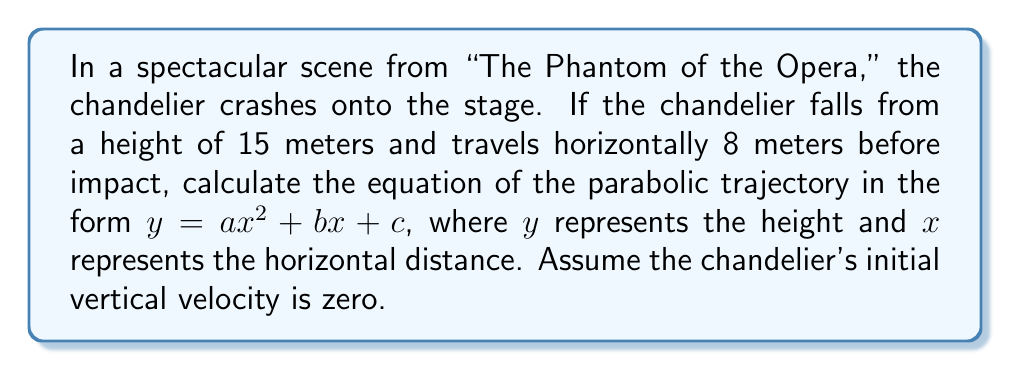Teach me how to tackle this problem. Let's approach this step-by-step:

1) The general equation for a parabola is $y = ax^2 + bx + c$, where:
   - $a$ determines the parabola's shape
   - $b$ affects the parabola's axis of symmetry
   - $c$ is the y-intercept (initial height)

2) We know three things:
   - The initial height (y-intercept) is 15 meters, so $c = 15$
   - The final height is 0 meters when x = 8 meters
   - The initial vertical velocity is zero, meaning the parabola is symmetrical

3) Because the parabola is symmetrical, its axis of symmetry is at $x = 4$ (half of 8).

4) For a symmetrical parabola, $b = -4a$ (where 4 is the x-coordinate of the axis of symmetry).

5) Now we can use the point (8, 0) to find $a$:

   $0 = a(8)^2 + (-4a)(8) + 15$
   $0 = 64a - 32a + 15$
   $32a = 15$
   $a = \frac{15}{32} = 0.46875$

6) Now we can find $b$:
   $b = -4a = -4(0.46875) = -1.875$

7) Therefore, the equation of the parabola is:
   $y = 0.46875x^2 - 1.875x + 15$
Answer: $y = 0.46875x^2 - 1.875x + 15$ 